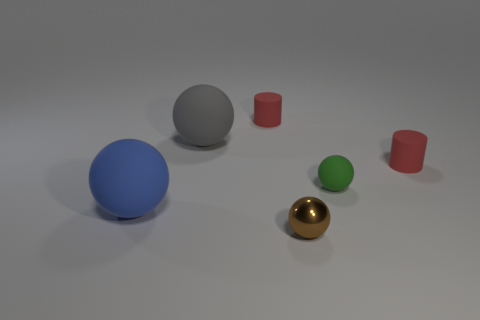The blue thing that is the same shape as the gray rubber thing is what size?
Ensure brevity in your answer.  Large. Is the number of brown shiny things on the right side of the brown metallic thing less than the number of big matte objects?
Your answer should be compact. Yes. Do the gray object and the small metallic thing have the same shape?
Offer a terse response. Yes. There is another metal object that is the same shape as the large gray thing; what is its color?
Your answer should be very brief. Brown. What number of things are spheres on the left side of the small shiny ball or big purple metal cylinders?
Provide a succinct answer. 2. There is a shiny ball that is in front of the large gray object; what size is it?
Keep it short and to the point. Small. Are there fewer blue matte spheres than red cylinders?
Offer a very short reply. Yes. Are the small red thing in front of the gray matte thing and the brown thing to the left of the green matte object made of the same material?
Give a very brief answer. No. What shape is the tiny rubber thing that is to the right of the matte sphere that is right of the brown object that is right of the big gray rubber object?
Your answer should be compact. Cylinder. How many big brown spheres have the same material as the tiny green thing?
Your answer should be compact. 0. 